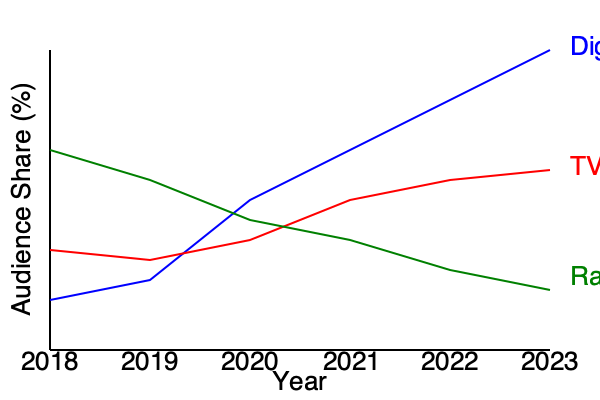Based on the media consumption trend line graph, which platform is projected to have the highest audience share by 2023, and what strategic implications does this have for media planning? To answer this question, we need to analyze the trends for each platform:

1. Digital (blue line):
   - Shows a consistent upward trend
   - Starts around 25% in 2018
   - Reaches approximately 60% by 2023

2. TV (red line):
   - Shows a gradual decline
   - Starts around 40% in 2018
   - Decreases to about 35% by 2023

3. Radio (green line):
   - Shows a slight increase
   - Starts around 35% in 2018
   - Rises to about 40% by 2023

Comparing the projected audience shares for 2023:
- Digital: ~60%
- TV: ~35%
- Radio: ~40%

Digital clearly has the highest projected audience share by 2023.

Strategic implications for media planning:

1. Budget allocation: Shift more advertising budget towards digital platforms to reach the largest audience.

2. Content adaptation: Develop more digital-friendly content and ad formats to engage the growing digital audience effectively.

3. Cross-platform integration: While focusing on digital, maintain a presence on TV and radio for a balanced media mix and to reach diverse audience segments.

4. Data-driven targeting: Leverage the increased digital consumption to gather more detailed audience data for precise targeting and personalization.

5. ROI optimization: Adjust ROI expectations and measurement metrics to align with the shift towards digital platforms.

6. Skill development: Invest in enhancing digital marketing skills within the media planning team to capitalize on the growing digital trend.

7. Emerging technologies: Stay ahead of new digital advertising technologies and platforms to maintain a competitive edge in the evolving media landscape.
Answer: Digital; shift budget to digital, adapt content, integrate cross-platform, leverage data-driven targeting, optimize ROI metrics, develop digital skills, and embrace emerging technologies. 